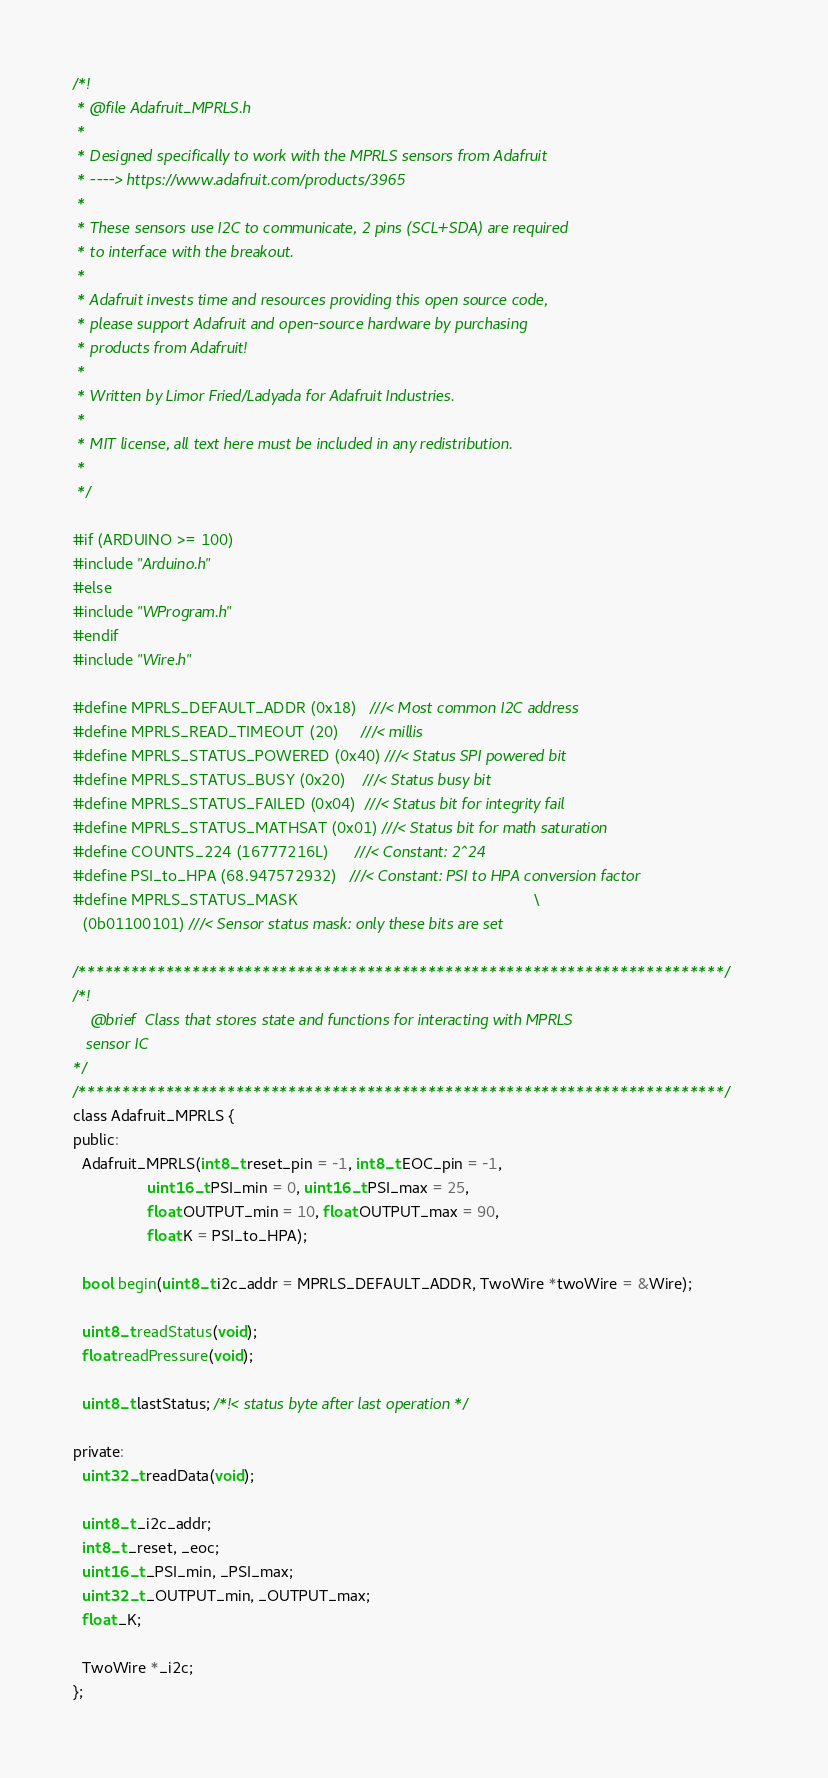Convert code to text. <code><loc_0><loc_0><loc_500><loc_500><_C_>/*!
 * @file Adafruit_MPRLS.h
 *
 * Designed specifically to work with the MPRLS sensors from Adafruit
 * ----> https://www.adafruit.com/products/3965
 *
 * These sensors use I2C to communicate, 2 pins (SCL+SDA) are required
 * to interface with the breakout.
 *
 * Adafruit invests time and resources providing this open source code,
 * please support Adafruit and open-source hardware by purchasing
 * products from Adafruit!
 *
 * Written by Limor Fried/Ladyada for Adafruit Industries.
 *
 * MIT license, all text here must be included in any redistribution.
 *
 */

#if (ARDUINO >= 100)
#include "Arduino.h"
#else
#include "WProgram.h"
#endif
#include "Wire.h"

#define MPRLS_DEFAULT_ADDR (0x18)   ///< Most common I2C address
#define MPRLS_READ_TIMEOUT (20)     ///< millis
#define MPRLS_STATUS_POWERED (0x40) ///< Status SPI powered bit
#define MPRLS_STATUS_BUSY (0x20)    ///< Status busy bit
#define MPRLS_STATUS_FAILED (0x04)  ///< Status bit for integrity fail
#define MPRLS_STATUS_MATHSAT (0x01) ///< Status bit for math saturation
#define COUNTS_224 (16777216L)      ///< Constant: 2^24
#define PSI_to_HPA (68.947572932)   ///< Constant: PSI to HPA conversion factor
#define MPRLS_STATUS_MASK                                                      \
  (0b01100101) ///< Sensor status mask: only these bits are set

/**************************************************************************/
/*!
    @brief  Class that stores state and functions for interacting with MPRLS
   sensor IC
*/
/**************************************************************************/
class Adafruit_MPRLS {
public:
  Adafruit_MPRLS(int8_t reset_pin = -1, int8_t EOC_pin = -1,
                 uint16_t PSI_min = 0, uint16_t PSI_max = 25,
                 float OUTPUT_min = 10, float OUTPUT_max = 90,
                 float K = PSI_to_HPA);

  bool begin(uint8_t i2c_addr = MPRLS_DEFAULT_ADDR, TwoWire *twoWire = &Wire);

  uint8_t readStatus(void);
  float readPressure(void);

  uint8_t lastStatus; /*!< status byte after last operation */

private:
  uint32_t readData(void);

  uint8_t _i2c_addr;
  int8_t _reset, _eoc;
  uint16_t _PSI_min, _PSI_max;
  uint32_t _OUTPUT_min, _OUTPUT_max;
  float _K;

  TwoWire *_i2c;
};
</code> 